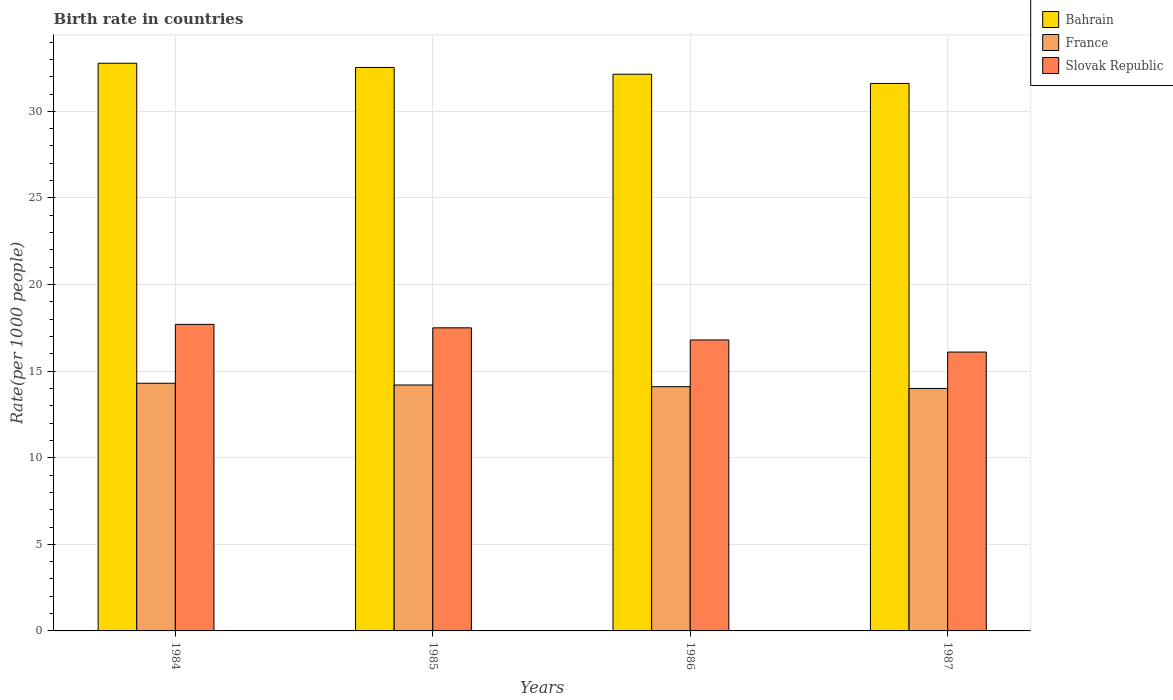How many different coloured bars are there?
Offer a very short reply. 3. How many groups of bars are there?
Your answer should be compact. 4. How many bars are there on the 4th tick from the left?
Keep it short and to the point. 3. How many bars are there on the 4th tick from the right?
Provide a succinct answer. 3. In how many cases, is the number of bars for a given year not equal to the number of legend labels?
Ensure brevity in your answer.  0. What is the birth rate in Bahrain in 1986?
Keep it short and to the point. 32.14. Across all years, what is the maximum birth rate in Slovak Republic?
Offer a terse response. 17.7. Across all years, what is the minimum birth rate in Slovak Republic?
Ensure brevity in your answer.  16.1. What is the total birth rate in France in the graph?
Give a very brief answer. 56.6. What is the difference between the birth rate in France in 1984 and that in 1986?
Offer a terse response. 0.2. What is the difference between the birth rate in Bahrain in 1986 and the birth rate in France in 1984?
Your answer should be very brief. 17.84. What is the average birth rate in Bahrain per year?
Provide a short and direct response. 32.27. In the year 1987, what is the difference between the birth rate in France and birth rate in Bahrain?
Give a very brief answer. -17.61. What is the ratio of the birth rate in France in 1986 to that in 1987?
Provide a short and direct response. 1.01. Is the birth rate in Slovak Republic in 1985 less than that in 1987?
Make the answer very short. No. Is the difference between the birth rate in France in 1986 and 1987 greater than the difference between the birth rate in Bahrain in 1986 and 1987?
Provide a short and direct response. No. What is the difference between the highest and the second highest birth rate in Slovak Republic?
Offer a terse response. 0.2. What is the difference between the highest and the lowest birth rate in Slovak Republic?
Offer a very short reply. 1.6. What does the 3rd bar from the left in 1985 represents?
Keep it short and to the point. Slovak Republic. What does the 1st bar from the right in 1985 represents?
Make the answer very short. Slovak Republic. Is it the case that in every year, the sum of the birth rate in Slovak Republic and birth rate in Bahrain is greater than the birth rate in France?
Provide a succinct answer. Yes. How many bars are there?
Provide a short and direct response. 12. Are the values on the major ticks of Y-axis written in scientific E-notation?
Offer a terse response. No. Where does the legend appear in the graph?
Ensure brevity in your answer.  Top right. How many legend labels are there?
Offer a very short reply. 3. What is the title of the graph?
Provide a succinct answer. Birth rate in countries. What is the label or title of the X-axis?
Ensure brevity in your answer.  Years. What is the label or title of the Y-axis?
Your response must be concise. Rate(per 1000 people). What is the Rate(per 1000 people) in Bahrain in 1984?
Provide a succinct answer. 32.78. What is the Rate(per 1000 people) of Bahrain in 1985?
Keep it short and to the point. 32.53. What is the Rate(per 1000 people) of Slovak Republic in 1985?
Give a very brief answer. 17.5. What is the Rate(per 1000 people) in Bahrain in 1986?
Your response must be concise. 32.14. What is the Rate(per 1000 people) of France in 1986?
Your answer should be compact. 14.1. What is the Rate(per 1000 people) in Bahrain in 1987?
Offer a very short reply. 31.61. What is the Rate(per 1000 people) of France in 1987?
Make the answer very short. 14. Across all years, what is the maximum Rate(per 1000 people) in Bahrain?
Your answer should be very brief. 32.78. Across all years, what is the minimum Rate(per 1000 people) of Bahrain?
Ensure brevity in your answer.  31.61. Across all years, what is the minimum Rate(per 1000 people) in Slovak Republic?
Your response must be concise. 16.1. What is the total Rate(per 1000 people) of Bahrain in the graph?
Provide a succinct answer. 129.06. What is the total Rate(per 1000 people) of France in the graph?
Your answer should be very brief. 56.6. What is the total Rate(per 1000 people) in Slovak Republic in the graph?
Ensure brevity in your answer.  68.1. What is the difference between the Rate(per 1000 people) of Bahrain in 1984 and that in 1985?
Ensure brevity in your answer.  0.24. What is the difference between the Rate(per 1000 people) in France in 1984 and that in 1985?
Your response must be concise. 0.1. What is the difference between the Rate(per 1000 people) in Slovak Republic in 1984 and that in 1985?
Give a very brief answer. 0.2. What is the difference between the Rate(per 1000 people) in Bahrain in 1984 and that in 1986?
Give a very brief answer. 0.63. What is the difference between the Rate(per 1000 people) of Bahrain in 1984 and that in 1987?
Keep it short and to the point. 1.17. What is the difference between the Rate(per 1000 people) in Slovak Republic in 1984 and that in 1987?
Offer a very short reply. 1.6. What is the difference between the Rate(per 1000 people) in Bahrain in 1985 and that in 1986?
Offer a very short reply. 0.39. What is the difference between the Rate(per 1000 people) in Bahrain in 1985 and that in 1987?
Your answer should be very brief. 0.92. What is the difference between the Rate(per 1000 people) in France in 1985 and that in 1987?
Make the answer very short. 0.2. What is the difference between the Rate(per 1000 people) of Bahrain in 1986 and that in 1987?
Your answer should be very brief. 0.53. What is the difference between the Rate(per 1000 people) of France in 1986 and that in 1987?
Offer a very short reply. 0.1. What is the difference between the Rate(per 1000 people) of Bahrain in 1984 and the Rate(per 1000 people) of France in 1985?
Provide a short and direct response. 18.58. What is the difference between the Rate(per 1000 people) in Bahrain in 1984 and the Rate(per 1000 people) in Slovak Republic in 1985?
Offer a very short reply. 15.28. What is the difference between the Rate(per 1000 people) in France in 1984 and the Rate(per 1000 people) in Slovak Republic in 1985?
Give a very brief answer. -3.2. What is the difference between the Rate(per 1000 people) in Bahrain in 1984 and the Rate(per 1000 people) in France in 1986?
Your response must be concise. 18.68. What is the difference between the Rate(per 1000 people) in Bahrain in 1984 and the Rate(per 1000 people) in Slovak Republic in 1986?
Your response must be concise. 15.98. What is the difference between the Rate(per 1000 people) in Bahrain in 1984 and the Rate(per 1000 people) in France in 1987?
Keep it short and to the point. 18.78. What is the difference between the Rate(per 1000 people) of Bahrain in 1984 and the Rate(per 1000 people) of Slovak Republic in 1987?
Make the answer very short. 16.68. What is the difference between the Rate(per 1000 people) of France in 1984 and the Rate(per 1000 people) of Slovak Republic in 1987?
Give a very brief answer. -1.8. What is the difference between the Rate(per 1000 people) of Bahrain in 1985 and the Rate(per 1000 people) of France in 1986?
Offer a terse response. 18.43. What is the difference between the Rate(per 1000 people) of Bahrain in 1985 and the Rate(per 1000 people) of Slovak Republic in 1986?
Your answer should be compact. 15.73. What is the difference between the Rate(per 1000 people) of Bahrain in 1985 and the Rate(per 1000 people) of France in 1987?
Your answer should be very brief. 18.53. What is the difference between the Rate(per 1000 people) in Bahrain in 1985 and the Rate(per 1000 people) in Slovak Republic in 1987?
Make the answer very short. 16.43. What is the difference between the Rate(per 1000 people) of France in 1985 and the Rate(per 1000 people) of Slovak Republic in 1987?
Provide a short and direct response. -1.9. What is the difference between the Rate(per 1000 people) of Bahrain in 1986 and the Rate(per 1000 people) of France in 1987?
Keep it short and to the point. 18.14. What is the difference between the Rate(per 1000 people) in Bahrain in 1986 and the Rate(per 1000 people) in Slovak Republic in 1987?
Offer a terse response. 16.04. What is the average Rate(per 1000 people) of Bahrain per year?
Provide a short and direct response. 32.27. What is the average Rate(per 1000 people) in France per year?
Keep it short and to the point. 14.15. What is the average Rate(per 1000 people) in Slovak Republic per year?
Offer a terse response. 17.02. In the year 1984, what is the difference between the Rate(per 1000 people) in Bahrain and Rate(per 1000 people) in France?
Provide a short and direct response. 18.48. In the year 1984, what is the difference between the Rate(per 1000 people) in Bahrain and Rate(per 1000 people) in Slovak Republic?
Provide a short and direct response. 15.08. In the year 1985, what is the difference between the Rate(per 1000 people) of Bahrain and Rate(per 1000 people) of France?
Keep it short and to the point. 18.33. In the year 1985, what is the difference between the Rate(per 1000 people) in Bahrain and Rate(per 1000 people) in Slovak Republic?
Make the answer very short. 15.03. In the year 1985, what is the difference between the Rate(per 1000 people) in France and Rate(per 1000 people) in Slovak Republic?
Provide a succinct answer. -3.3. In the year 1986, what is the difference between the Rate(per 1000 people) in Bahrain and Rate(per 1000 people) in France?
Provide a short and direct response. 18.04. In the year 1986, what is the difference between the Rate(per 1000 people) of Bahrain and Rate(per 1000 people) of Slovak Republic?
Your answer should be compact. 15.34. In the year 1987, what is the difference between the Rate(per 1000 people) in Bahrain and Rate(per 1000 people) in France?
Your answer should be compact. 17.61. In the year 1987, what is the difference between the Rate(per 1000 people) of Bahrain and Rate(per 1000 people) of Slovak Republic?
Provide a short and direct response. 15.51. In the year 1987, what is the difference between the Rate(per 1000 people) of France and Rate(per 1000 people) of Slovak Republic?
Offer a very short reply. -2.1. What is the ratio of the Rate(per 1000 people) in Bahrain in 1984 to that in 1985?
Ensure brevity in your answer.  1.01. What is the ratio of the Rate(per 1000 people) in France in 1984 to that in 1985?
Offer a very short reply. 1.01. What is the ratio of the Rate(per 1000 people) in Slovak Republic in 1984 to that in 1985?
Offer a terse response. 1.01. What is the ratio of the Rate(per 1000 people) in Bahrain in 1984 to that in 1986?
Give a very brief answer. 1.02. What is the ratio of the Rate(per 1000 people) of France in 1984 to that in 1986?
Keep it short and to the point. 1.01. What is the ratio of the Rate(per 1000 people) of Slovak Republic in 1984 to that in 1986?
Give a very brief answer. 1.05. What is the ratio of the Rate(per 1000 people) in Bahrain in 1984 to that in 1987?
Make the answer very short. 1.04. What is the ratio of the Rate(per 1000 people) of France in 1984 to that in 1987?
Offer a terse response. 1.02. What is the ratio of the Rate(per 1000 people) in Slovak Republic in 1984 to that in 1987?
Provide a succinct answer. 1.1. What is the ratio of the Rate(per 1000 people) in Bahrain in 1985 to that in 1986?
Make the answer very short. 1.01. What is the ratio of the Rate(per 1000 people) in France in 1985 to that in 1986?
Ensure brevity in your answer.  1.01. What is the ratio of the Rate(per 1000 people) in Slovak Republic in 1985 to that in 1986?
Make the answer very short. 1.04. What is the ratio of the Rate(per 1000 people) of Bahrain in 1985 to that in 1987?
Make the answer very short. 1.03. What is the ratio of the Rate(per 1000 people) in France in 1985 to that in 1987?
Offer a very short reply. 1.01. What is the ratio of the Rate(per 1000 people) in Slovak Republic in 1985 to that in 1987?
Provide a succinct answer. 1.09. What is the ratio of the Rate(per 1000 people) of Bahrain in 1986 to that in 1987?
Your response must be concise. 1.02. What is the ratio of the Rate(per 1000 people) of France in 1986 to that in 1987?
Ensure brevity in your answer.  1.01. What is the ratio of the Rate(per 1000 people) in Slovak Republic in 1986 to that in 1987?
Offer a terse response. 1.04. What is the difference between the highest and the second highest Rate(per 1000 people) of Bahrain?
Your answer should be compact. 0.24. What is the difference between the highest and the second highest Rate(per 1000 people) in France?
Give a very brief answer. 0.1. What is the difference between the highest and the lowest Rate(per 1000 people) of Bahrain?
Give a very brief answer. 1.17. What is the difference between the highest and the lowest Rate(per 1000 people) in France?
Offer a very short reply. 0.3. What is the difference between the highest and the lowest Rate(per 1000 people) of Slovak Republic?
Offer a terse response. 1.6. 